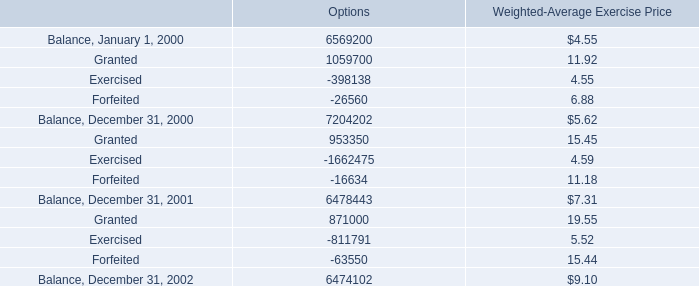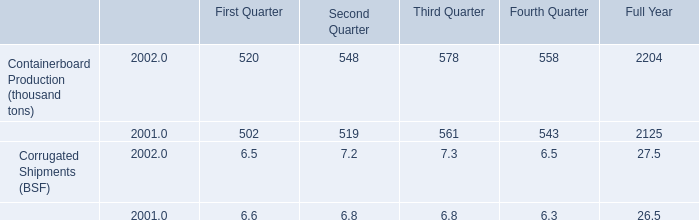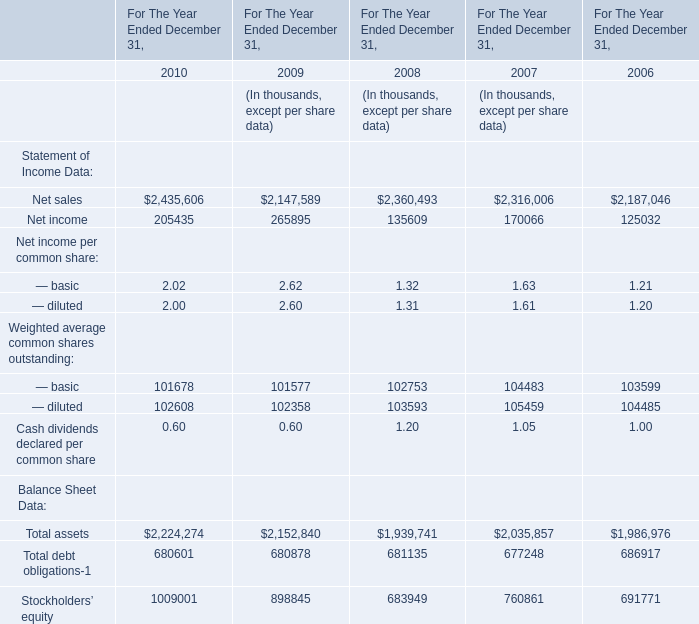Does Net sales keeps increasing each year between 2009 and 2010? 
Answer: Yes. 